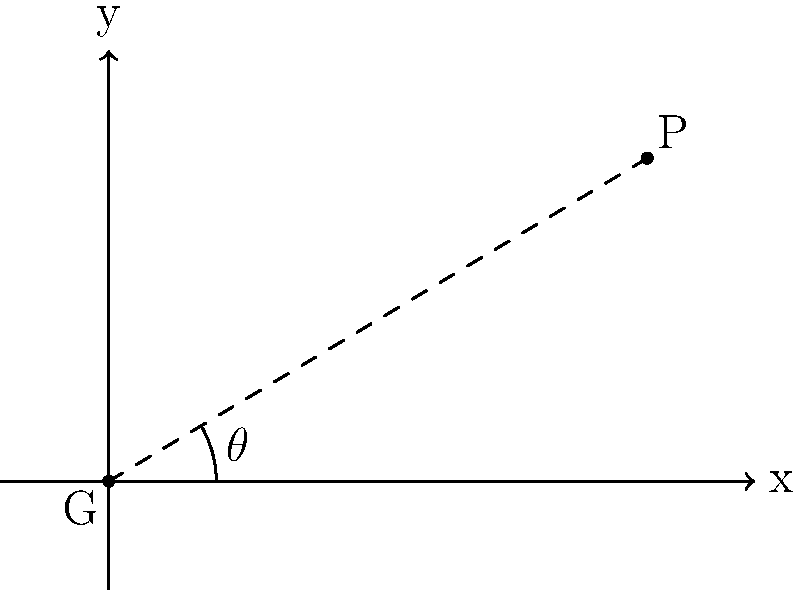In a hockey game against the St. Louis Blues, a player is positioned at coordinates (5,3) relative to the goal, which is at (0,0). The x-axis represents the goal line, and the y-axis represents the perpendicular line from the center of the goal. What is the shot angle $\theta$ in degrees, rounded to the nearest whole number, from the player's position to the goal? To find the shot angle, we need to use the arctangent function. Here's how we calculate it:

1) The player's coordinates are (5,3), so we have a right triangle with:
   - Adjacent side (x-coordinate) = 5
   - Opposite side (y-coordinate) = 3

2) The tangent of the angle is the ratio of opposite to adjacent:
   $\tan(\theta) = \frac{\text{opposite}}{\text{adjacent}} = \frac{3}{5}$

3) To find $\theta$, we take the arctangent (inverse tangent) of this ratio:
   $\theta = \arctan(\frac{3}{5})$

4) Using a calculator or programming function:
   $\theta \approx 0.5404195002705842$ radians

5) Convert radians to degrees:
   $\theta \approx 0.5404195002705842 \times \frac{180}{\pi} \approx 30.96375653207352°$

6) Rounding to the nearest whole number:
   $\theta \approx 31°$
Answer: 31° 